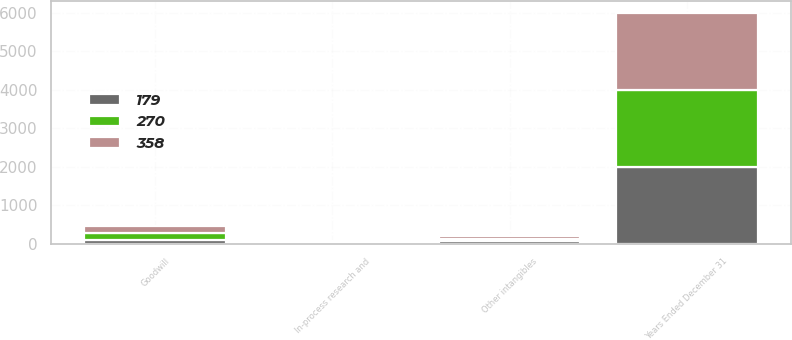<chart> <loc_0><loc_0><loc_500><loc_500><stacked_bar_chart><ecel><fcel>Years Ended December 31<fcel>Goodwill<fcel>Other intangibles<fcel>In-process research and<nl><fcel>270<fcel>2004<fcel>178<fcel>70<fcel>33<nl><fcel>179<fcel>2003<fcel>93<fcel>54<fcel>32<nl><fcel>358<fcel>2002<fcel>194<fcel>61<fcel>11<nl></chart> 